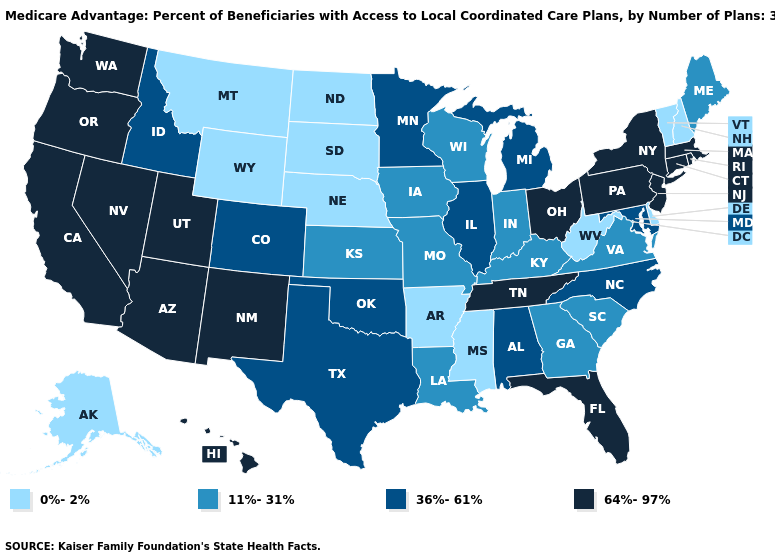Which states have the lowest value in the South?
Be succinct. Arkansas, Delaware, Mississippi, West Virginia. Among the states that border Montana , does North Dakota have the highest value?
Keep it brief. No. What is the value of California?
Give a very brief answer. 64%-97%. Which states have the lowest value in the South?
Write a very short answer. Arkansas, Delaware, Mississippi, West Virginia. Is the legend a continuous bar?
Be succinct. No. Name the states that have a value in the range 0%-2%?
Be succinct. Alaska, Arkansas, Delaware, Mississippi, Montana, North Dakota, Nebraska, New Hampshire, South Dakota, Vermont, West Virginia, Wyoming. What is the value of Iowa?
Short answer required. 11%-31%. Is the legend a continuous bar?
Give a very brief answer. No. Which states have the lowest value in the USA?
Answer briefly. Alaska, Arkansas, Delaware, Mississippi, Montana, North Dakota, Nebraska, New Hampshire, South Dakota, Vermont, West Virginia, Wyoming. What is the highest value in states that border New York?
Answer briefly. 64%-97%. Is the legend a continuous bar?
Short answer required. No. Name the states that have a value in the range 64%-97%?
Concise answer only. Arizona, California, Connecticut, Florida, Hawaii, Massachusetts, New Jersey, New Mexico, Nevada, New York, Ohio, Oregon, Pennsylvania, Rhode Island, Tennessee, Utah, Washington. What is the value of Massachusetts?
Quick response, please. 64%-97%. Does the map have missing data?
Concise answer only. No. Name the states that have a value in the range 11%-31%?
Keep it brief. Georgia, Iowa, Indiana, Kansas, Kentucky, Louisiana, Maine, Missouri, South Carolina, Virginia, Wisconsin. 